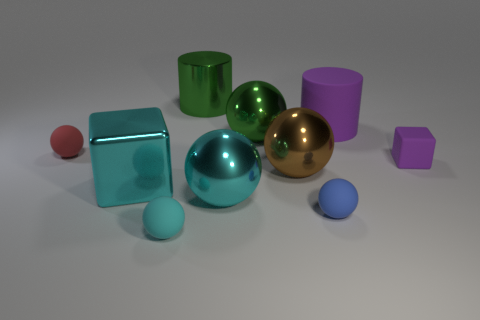Subtract all small blue balls. How many balls are left? 5 Subtract all green balls. How many balls are left? 5 Subtract all blue balls. Subtract all yellow cubes. How many balls are left? 5 Subtract all balls. How many objects are left? 4 Add 2 large brown balls. How many large brown balls exist? 3 Subtract 0 yellow cylinders. How many objects are left? 10 Subtract all cubes. Subtract all green rubber things. How many objects are left? 8 Add 2 big matte cylinders. How many big matte cylinders are left? 3 